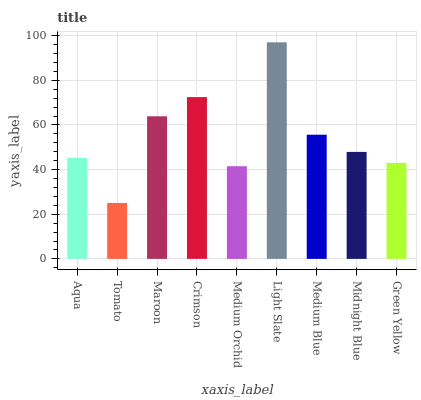Is Tomato the minimum?
Answer yes or no. Yes. Is Light Slate the maximum?
Answer yes or no. Yes. Is Maroon the minimum?
Answer yes or no. No. Is Maroon the maximum?
Answer yes or no. No. Is Maroon greater than Tomato?
Answer yes or no. Yes. Is Tomato less than Maroon?
Answer yes or no. Yes. Is Tomato greater than Maroon?
Answer yes or no. No. Is Maroon less than Tomato?
Answer yes or no. No. Is Midnight Blue the high median?
Answer yes or no. Yes. Is Midnight Blue the low median?
Answer yes or no. Yes. Is Maroon the high median?
Answer yes or no. No. Is Medium Blue the low median?
Answer yes or no. No. 